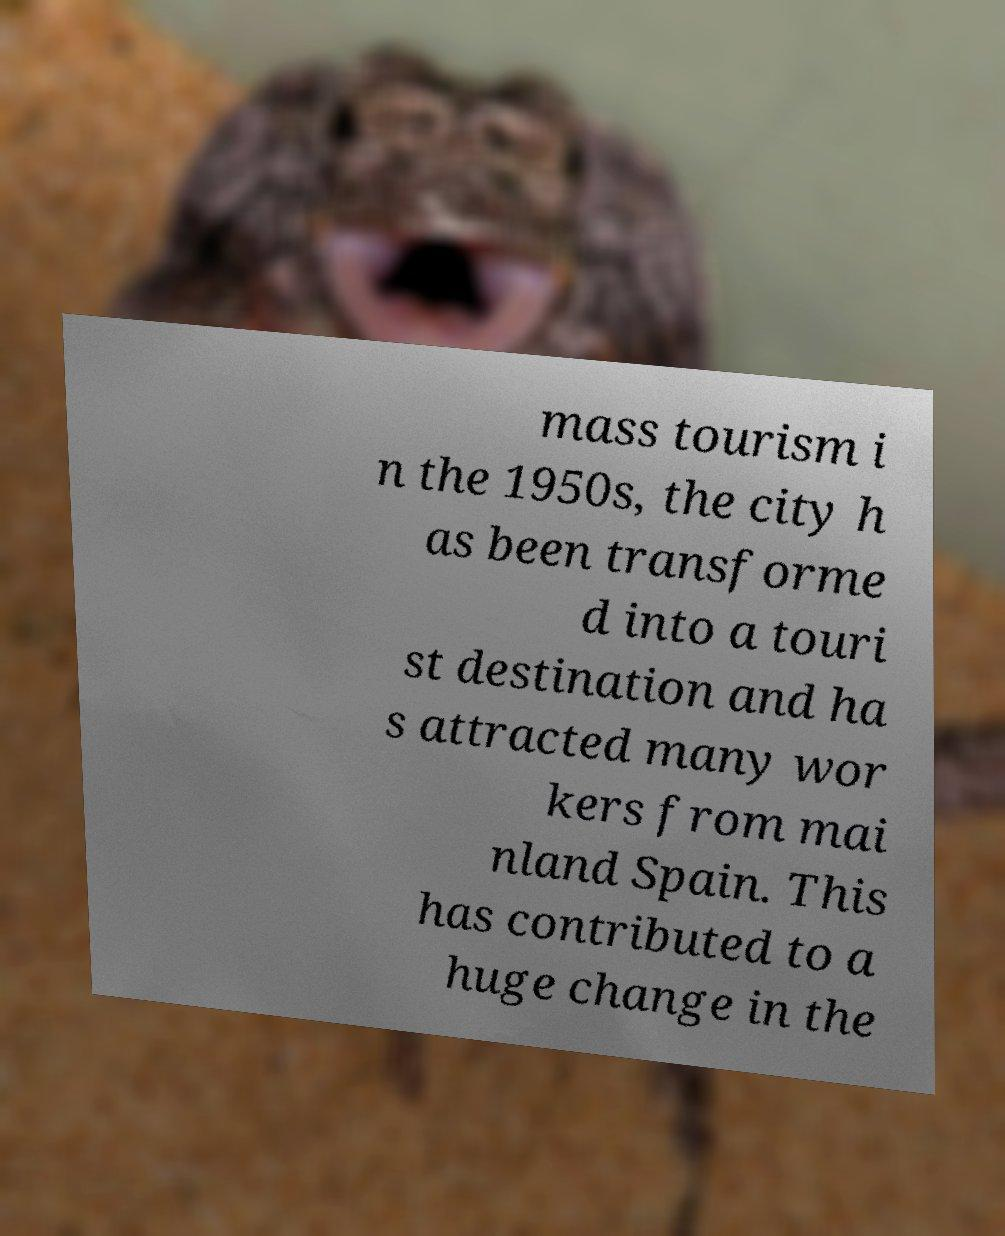Please identify and transcribe the text found in this image. mass tourism i n the 1950s, the city h as been transforme d into a touri st destination and ha s attracted many wor kers from mai nland Spain. This has contributed to a huge change in the 